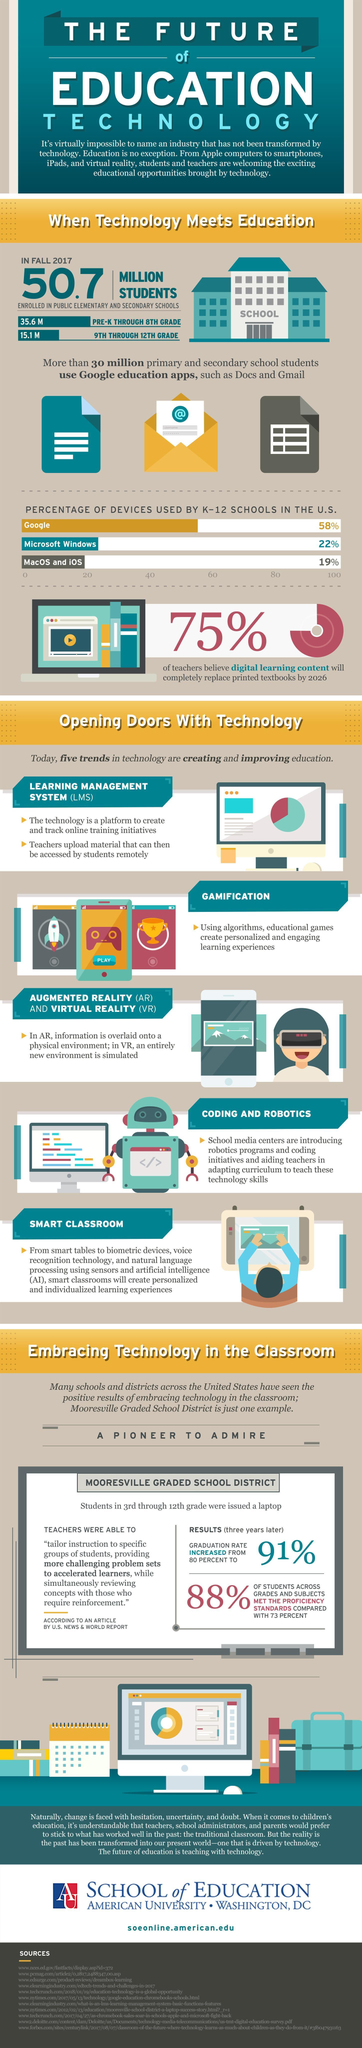What is the percentage of MacOS and iOS used by K-12 schools in the U.S.?
Answer the question with a short phrase. 19% What is the number of students enrolled in public elementary & secondary shools in U.S. in Fall 2017? 50.7 MILLION What is the percentage of google devices used by K-12 schools in the U.S.? 58% Which device is least used by K-12 schools in the U.S.? MacOS and iOS Which device is used mostly by K-12 schools in the U.S.? Google 